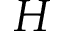<formula> <loc_0><loc_0><loc_500><loc_500>H</formula> 